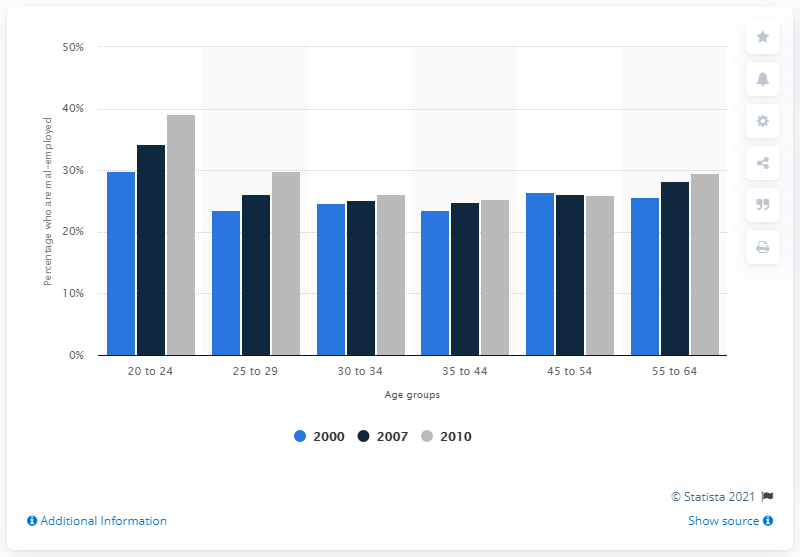Identify some key points in this picture. In 2010, the mal-employment rate for individuals aged 20 to 24 was 39.1%. In 2000, the youth unemployment rate, which refers to the percentage of 20-24 year olds who are not employed but are actively seeking work, was 29.8%. 